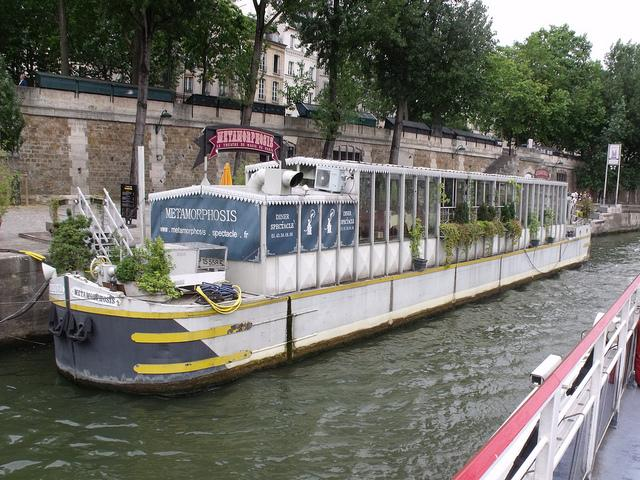Who wrote a book whose title matches the word at the front top of the boat? Please explain your reasoning. franz kafka. He had a book with that word in the title and is known for that work that he did. 